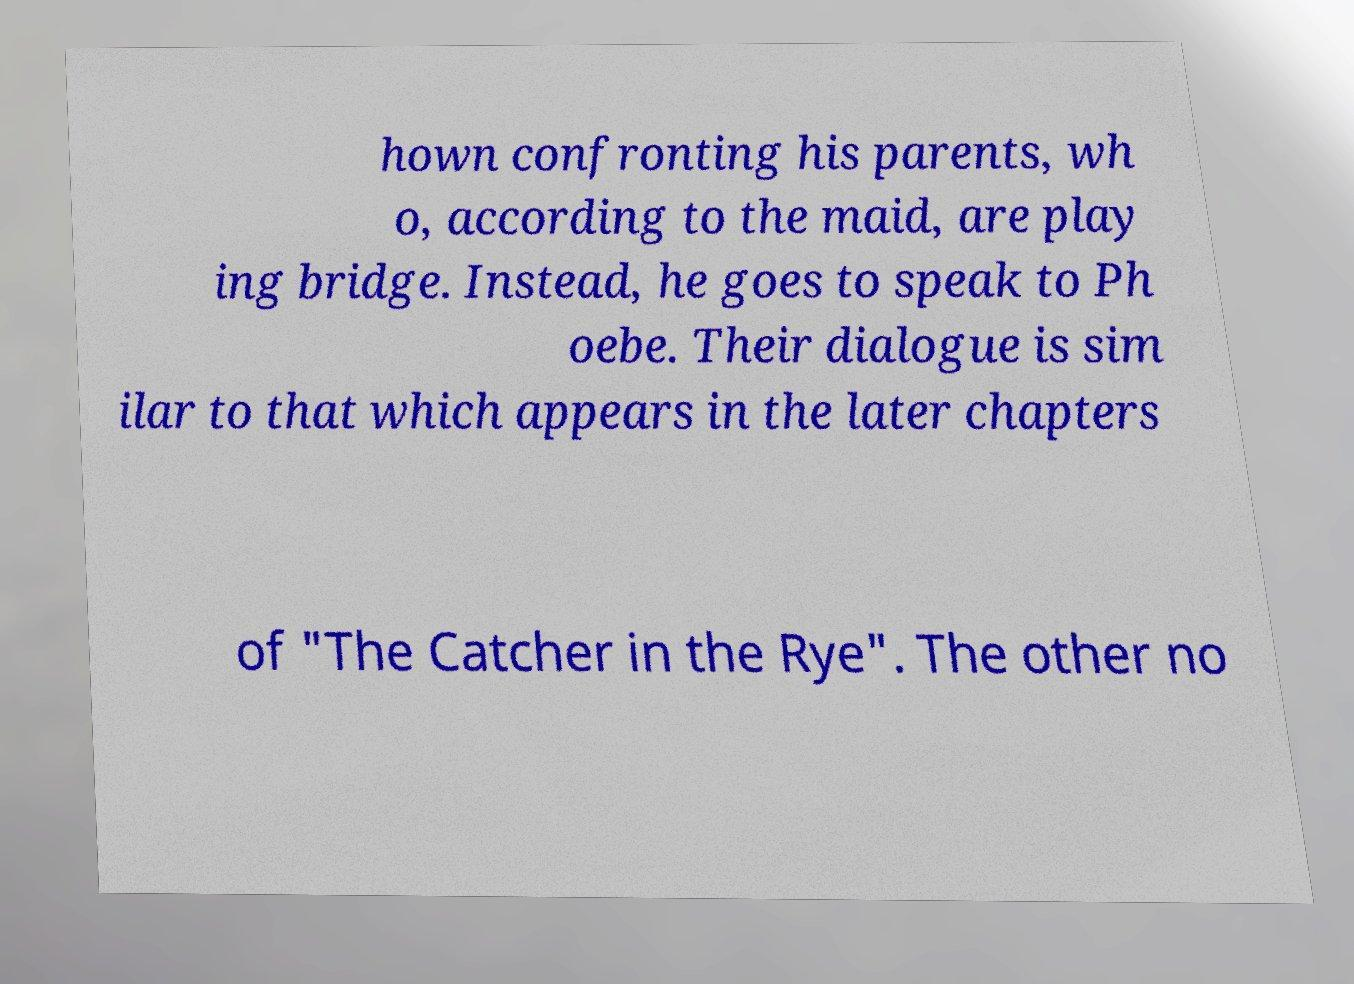Could you assist in decoding the text presented in this image and type it out clearly? hown confronting his parents, wh o, according to the maid, are play ing bridge. Instead, he goes to speak to Ph oebe. Their dialogue is sim ilar to that which appears in the later chapters of "The Catcher in the Rye". The other no 